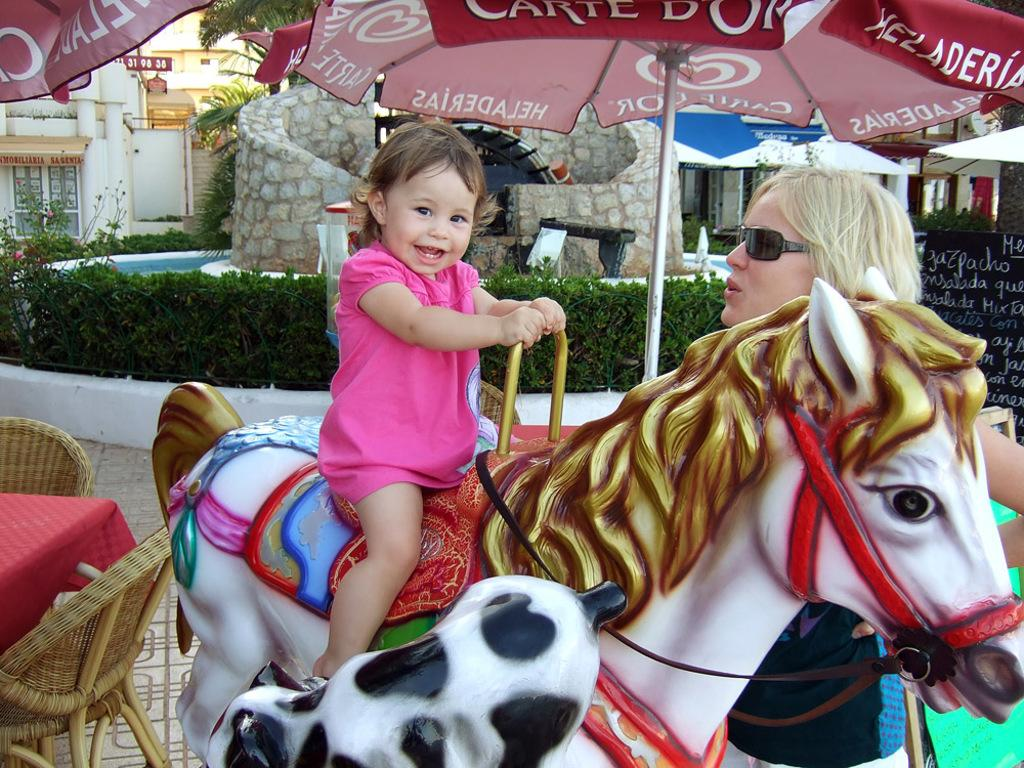What type of structures can be seen in the image? There are buildings in the image. What object is present for protection from the elements? There is an umbrella in the image. What type of vegetation is visible in the image? There are plants in the image. What type of furniture is present in the image? There is a table and chairs in the image. What is the girl doing in the image? The girl is sitting on a toy horse in the image. Where is the woman located in the image? The woman is on the right side of the image. What type of copper material is present in the image? There is no copper material present in the image. What type of exchange is taking place between the girl and the woman in the image? There is no exchange taking place between the girl and the woman in the image. 